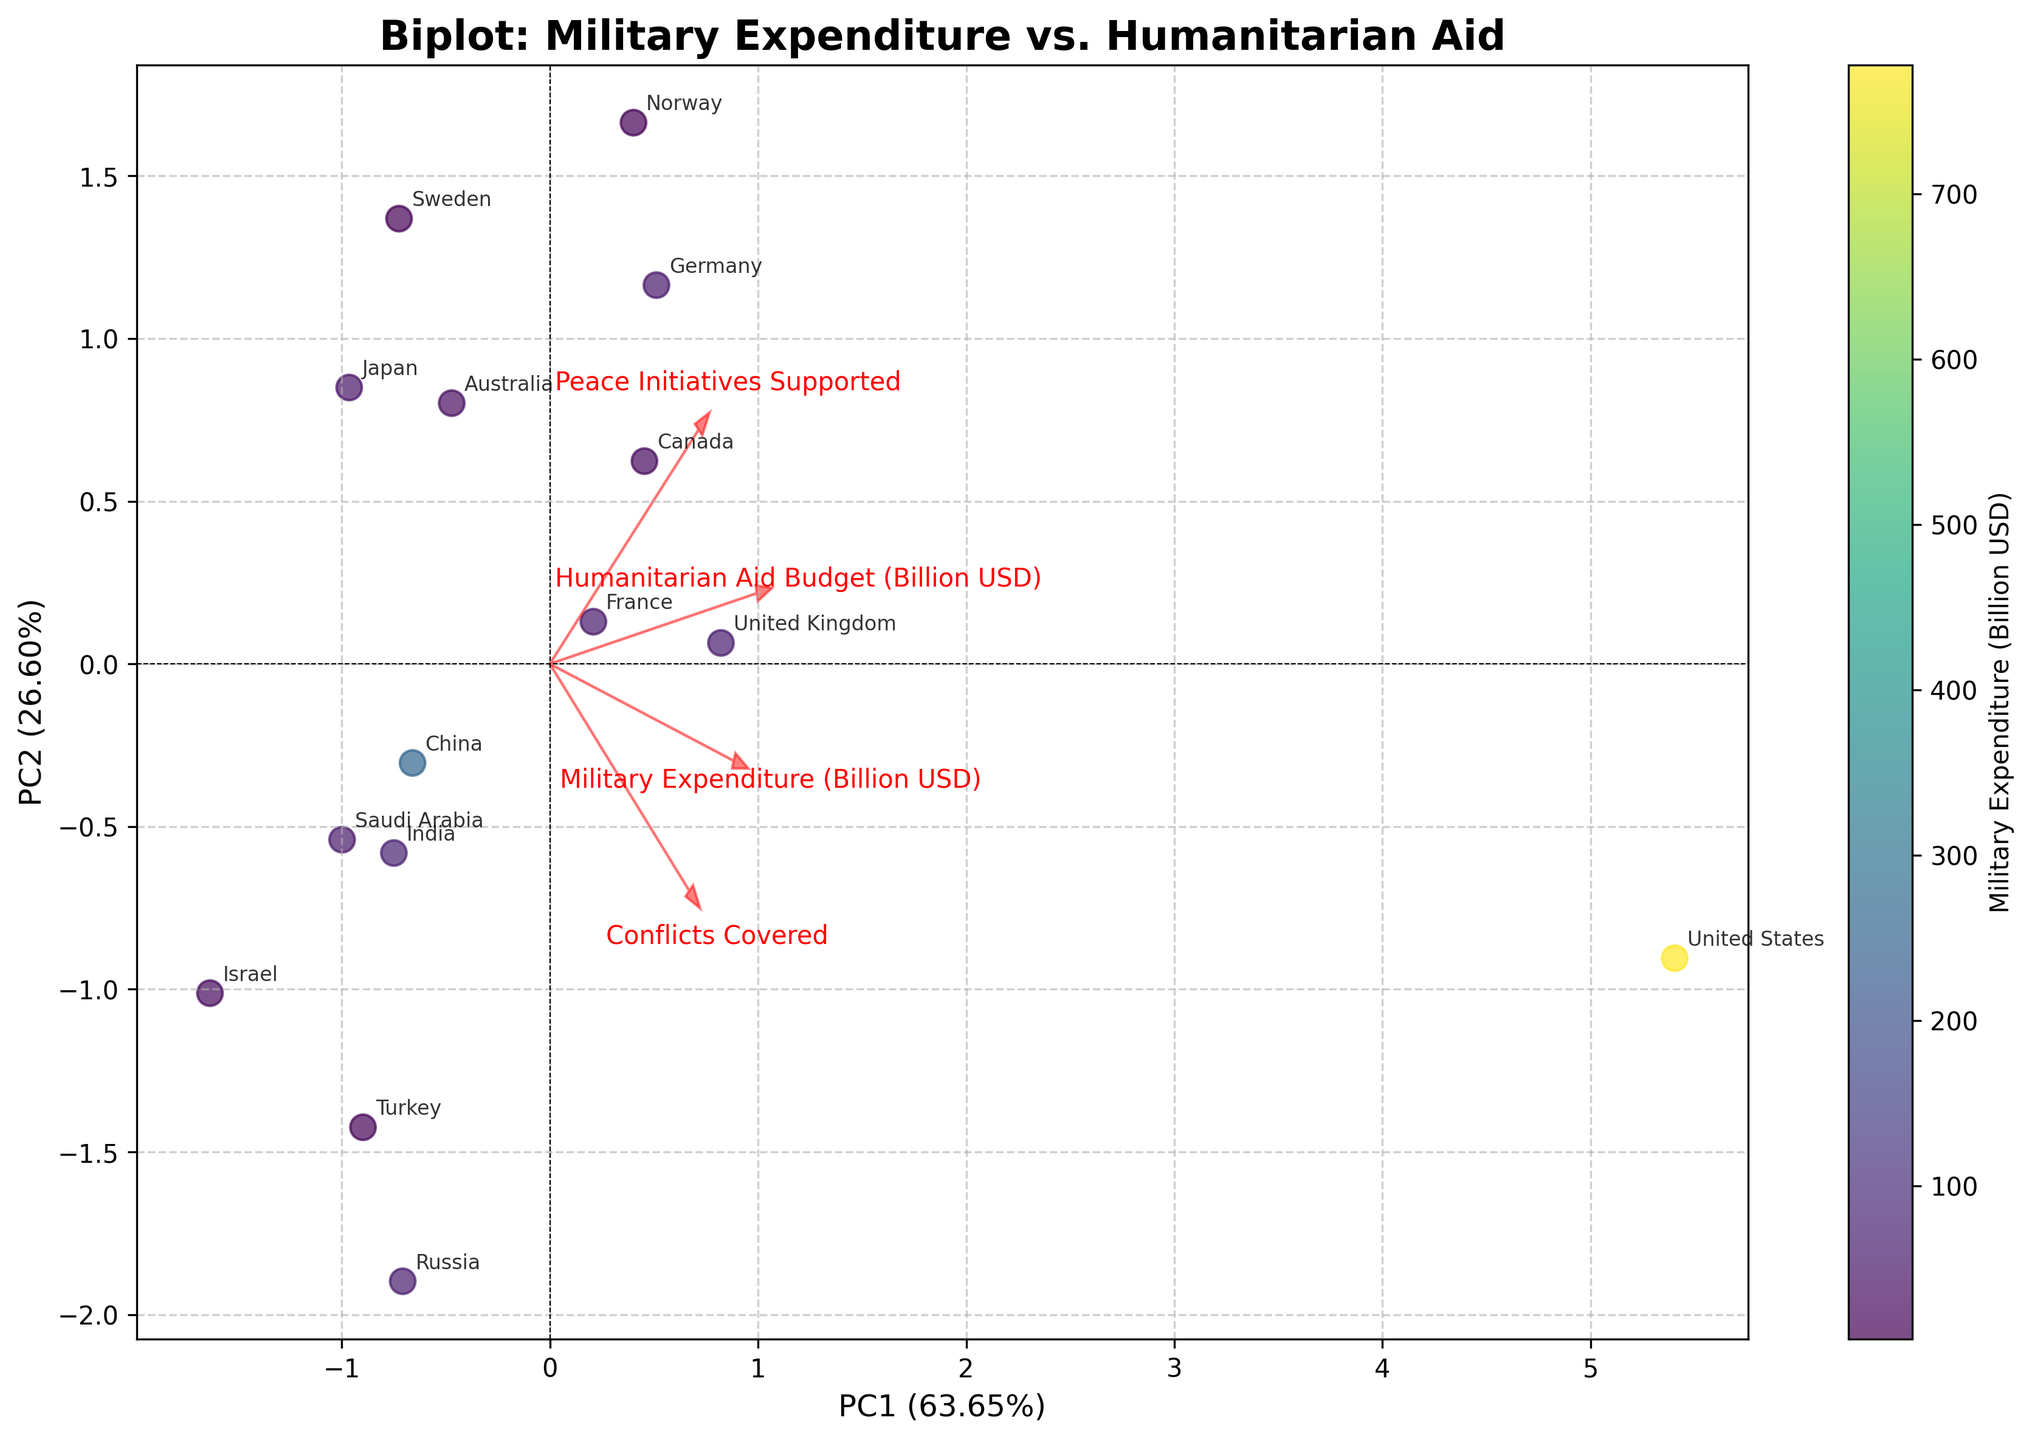What's the title of the plot? The title of the plot is written at the top center of the figure.
Answer: Biplot: Military Expenditure vs. Humanitarian Aid How many countries are labeled on the plot? There are labels for each data point, which correspond to the countries. Count the number of labels displayed to find the total.
Answer: 15 Which country has the highest military expenditure? The color bar represents military expenditure, and brighter colors (yellowish) indicate higher values. Observe the data point with the brightest color.
Answer: United States What features are represented by the arrows in the biplot? The arrows are annotated with text labels that indicate which features they represent.
Answer: Military Expenditure (Billion USD), Humanitarian Aid Budget (Billion USD), Conflicts Covered, Peace Initiatives Supported Which country is projected furthest along PC1? Look at the x-axis (PC1), and find the country whose data point has the highest absolute value.
Answer: United States Compare military expenditure between the United Kingdom and Germany. Which one spends more? Check the color shade of the data points for the United Kingdom and Germany, then refer to the color bar to determine which one has a higher expenditure.
Answer: United Kingdom How do the peace initiatives supported correlate with PC2? Observe the direction of the arrow for "Peace Initiatives Supported" and see if PC2 is positively or negatively correlated with it.
Answer: Positively correlated Which countries cluster around the origin? Examine data points close to (0,0) on the plot and note the countries they represent.
Answer: Sweden, Norway How much of the variance is explained by PC1 and PC2 together? The explained variance percentages are labeled on the axes for PC1 and PC2. Add them together.
Answer: About 67.66% Which country has the highest humanitarian aid budget? Review the position of the data points along the vector for "Humanitarian Aid Budget (Billion USD)" and identify the country furthest in that direction.
Answer: Norway 